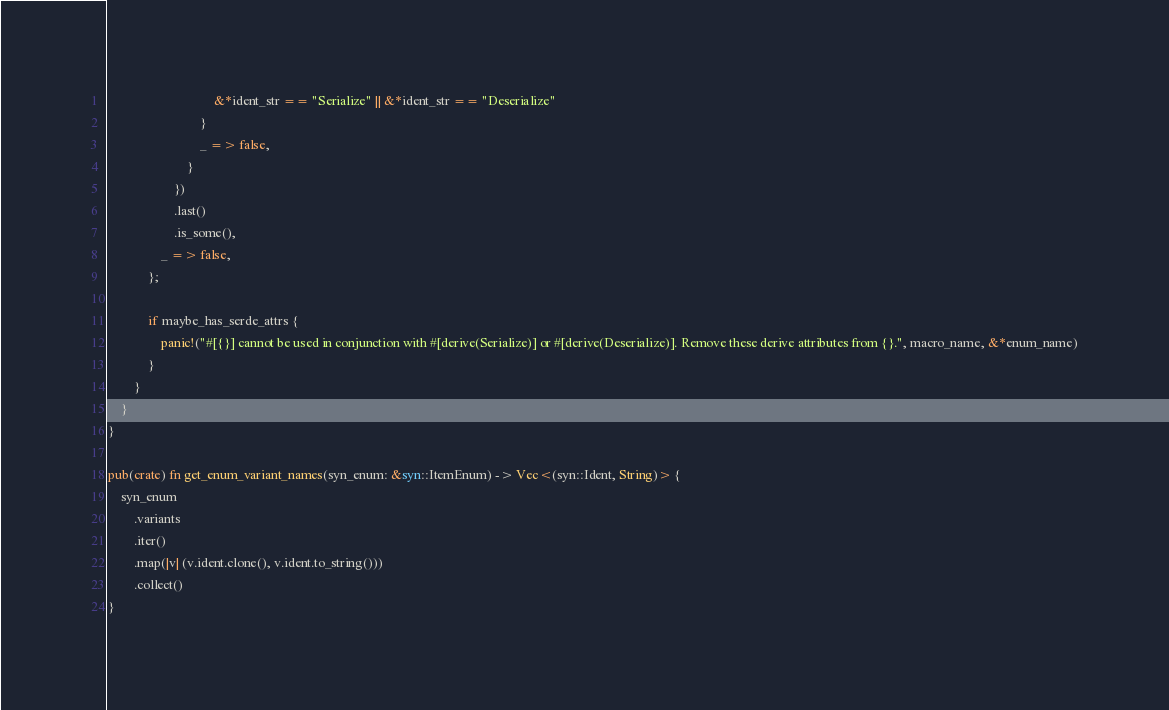Convert code to text. <code><loc_0><loc_0><loc_500><loc_500><_Rust_>                                &*ident_str == "Serialize" || &*ident_str == "Deserialize"
                            }
                            _ => false,
                        }
                    })
                    .last()
                    .is_some(),
                _ => false,
            };

            if maybe_has_serde_attrs {
                panic!("#[{}] cannot be used in conjunction with #[derive(Serialize)] or #[derive(Deserialize)]. Remove these derive attributes from {}.", macro_name, &*enum_name)
            }
        }
    }
}

pub(crate) fn get_enum_variant_names(syn_enum: &syn::ItemEnum) -> Vec<(syn::Ident, String)> {
    syn_enum
        .variants
        .iter()
        .map(|v| (v.ident.clone(), v.ident.to_string()))
        .collect()
}
</code> 